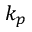<formula> <loc_0><loc_0><loc_500><loc_500>k _ { p }</formula> 